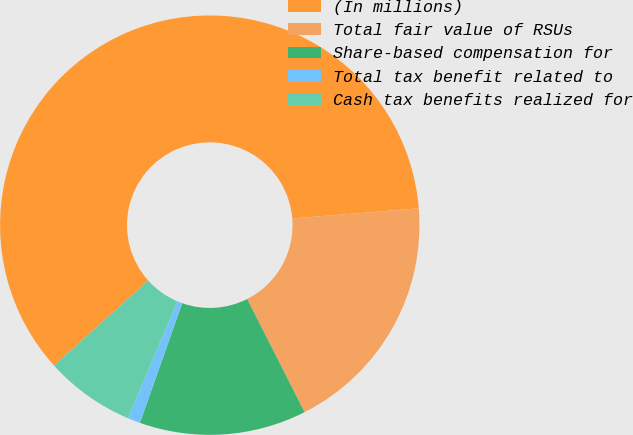<chart> <loc_0><loc_0><loc_500><loc_500><pie_chart><fcel>(In millions)<fcel>Total fair value of RSUs<fcel>Share-based compensation for<fcel>Total tax benefit related to<fcel>Cash tax benefits realized for<nl><fcel>60.39%<fcel>18.81%<fcel>12.87%<fcel>0.99%<fcel>6.93%<nl></chart> 